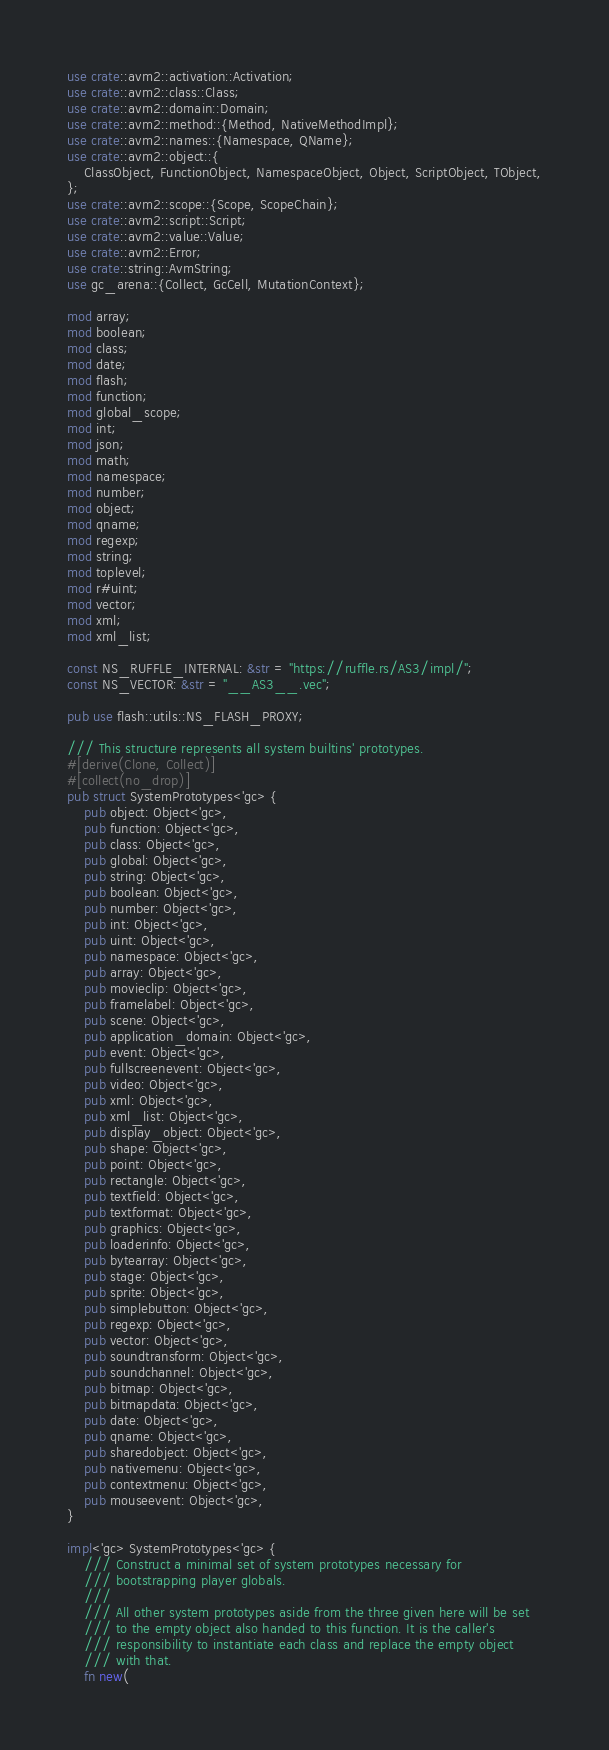<code> <loc_0><loc_0><loc_500><loc_500><_Rust_>use crate::avm2::activation::Activation;
use crate::avm2::class::Class;
use crate::avm2::domain::Domain;
use crate::avm2::method::{Method, NativeMethodImpl};
use crate::avm2::names::{Namespace, QName};
use crate::avm2::object::{
    ClassObject, FunctionObject, NamespaceObject, Object, ScriptObject, TObject,
};
use crate::avm2::scope::{Scope, ScopeChain};
use crate::avm2::script::Script;
use crate::avm2::value::Value;
use crate::avm2::Error;
use crate::string::AvmString;
use gc_arena::{Collect, GcCell, MutationContext};

mod array;
mod boolean;
mod class;
mod date;
mod flash;
mod function;
mod global_scope;
mod int;
mod json;
mod math;
mod namespace;
mod number;
mod object;
mod qname;
mod regexp;
mod string;
mod toplevel;
mod r#uint;
mod vector;
mod xml;
mod xml_list;

const NS_RUFFLE_INTERNAL: &str = "https://ruffle.rs/AS3/impl/";
const NS_VECTOR: &str = "__AS3__.vec";

pub use flash::utils::NS_FLASH_PROXY;

/// This structure represents all system builtins' prototypes.
#[derive(Clone, Collect)]
#[collect(no_drop)]
pub struct SystemPrototypes<'gc> {
    pub object: Object<'gc>,
    pub function: Object<'gc>,
    pub class: Object<'gc>,
    pub global: Object<'gc>,
    pub string: Object<'gc>,
    pub boolean: Object<'gc>,
    pub number: Object<'gc>,
    pub int: Object<'gc>,
    pub uint: Object<'gc>,
    pub namespace: Object<'gc>,
    pub array: Object<'gc>,
    pub movieclip: Object<'gc>,
    pub framelabel: Object<'gc>,
    pub scene: Object<'gc>,
    pub application_domain: Object<'gc>,
    pub event: Object<'gc>,
    pub fullscreenevent: Object<'gc>,
    pub video: Object<'gc>,
    pub xml: Object<'gc>,
    pub xml_list: Object<'gc>,
    pub display_object: Object<'gc>,
    pub shape: Object<'gc>,
    pub point: Object<'gc>,
    pub rectangle: Object<'gc>,
    pub textfield: Object<'gc>,
    pub textformat: Object<'gc>,
    pub graphics: Object<'gc>,
    pub loaderinfo: Object<'gc>,
    pub bytearray: Object<'gc>,
    pub stage: Object<'gc>,
    pub sprite: Object<'gc>,
    pub simplebutton: Object<'gc>,
    pub regexp: Object<'gc>,
    pub vector: Object<'gc>,
    pub soundtransform: Object<'gc>,
    pub soundchannel: Object<'gc>,
    pub bitmap: Object<'gc>,
    pub bitmapdata: Object<'gc>,
    pub date: Object<'gc>,
    pub qname: Object<'gc>,
    pub sharedobject: Object<'gc>,
    pub nativemenu: Object<'gc>,
    pub contextmenu: Object<'gc>,
    pub mouseevent: Object<'gc>,
}

impl<'gc> SystemPrototypes<'gc> {
    /// Construct a minimal set of system prototypes necessary for
    /// bootstrapping player globals.
    ///
    /// All other system prototypes aside from the three given here will be set
    /// to the empty object also handed to this function. It is the caller's
    /// responsibility to instantiate each class and replace the empty object
    /// with that.
    fn new(</code> 